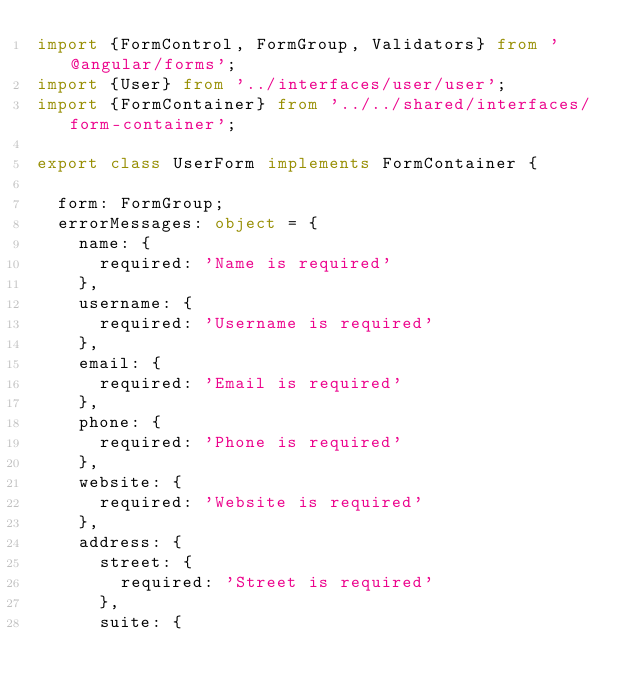<code> <loc_0><loc_0><loc_500><loc_500><_TypeScript_>import {FormControl, FormGroup, Validators} from '@angular/forms';
import {User} from '../interfaces/user/user';
import {FormContainer} from '../../shared/interfaces/form-container';

export class UserForm implements FormContainer {

  form: FormGroup;
  errorMessages: object = {
    name: {
      required: 'Name is required'
    },
    username: {
      required: 'Username is required'
    },
    email: {
      required: 'Email is required'
    },
    phone: {
      required: 'Phone is required'
    },
    website: {
      required: 'Website is required'
    },
    address: {
      street: {
        required: 'Street is required'
      },
      suite: {</code> 